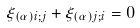<formula> <loc_0><loc_0><loc_500><loc_500>\xi _ { ( \alpha ) i ; j } + \xi _ { ( \alpha ) j ; i } = 0</formula> 